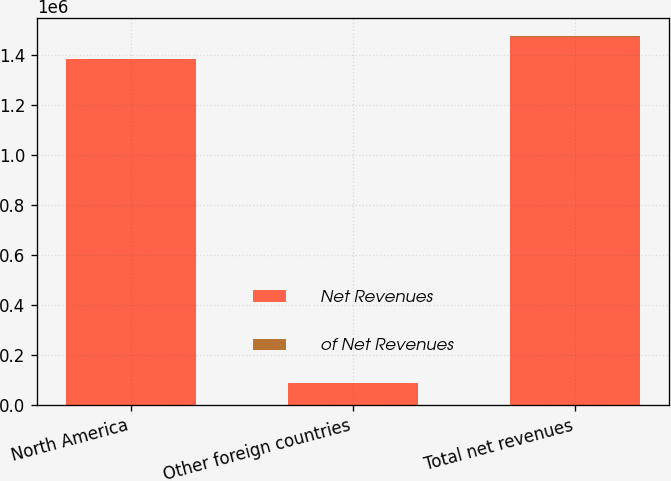Convert chart. <chart><loc_0><loc_0><loc_500><loc_500><stacked_bar_chart><ecel><fcel>North America<fcel>Other foreign countries<fcel>Total net revenues<nl><fcel>Net Revenues<fcel>1.38335e+06<fcel>89338<fcel>1.47268e+06<nl><fcel>of Net Revenues<fcel>93.9<fcel>6.1<fcel>100<nl></chart> 